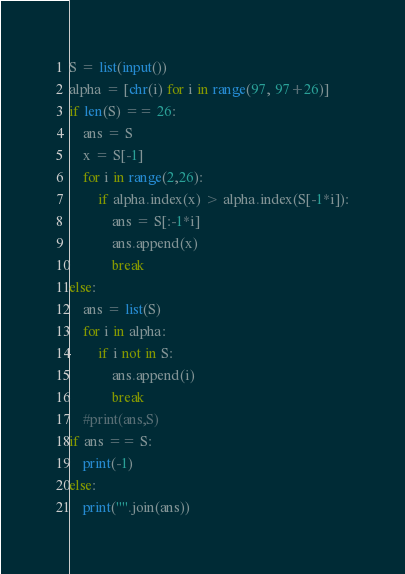<code> <loc_0><loc_0><loc_500><loc_500><_Python_>S = list(input())
alpha = [chr(i) for i in range(97, 97+26)]
if len(S) == 26:
    ans = S
    x = S[-1]
    for i in range(2,26):
        if alpha.index(x) > alpha.index(S[-1*i]):
            ans = S[:-1*i]
            ans.append(x)
            break
else:
    ans = list(S)
    for i in alpha:
        if i not in S:
            ans.append(i)
            break
    #print(ans,S)
if ans == S:
    print(-1)
else:   
    print("".join(ans))</code> 